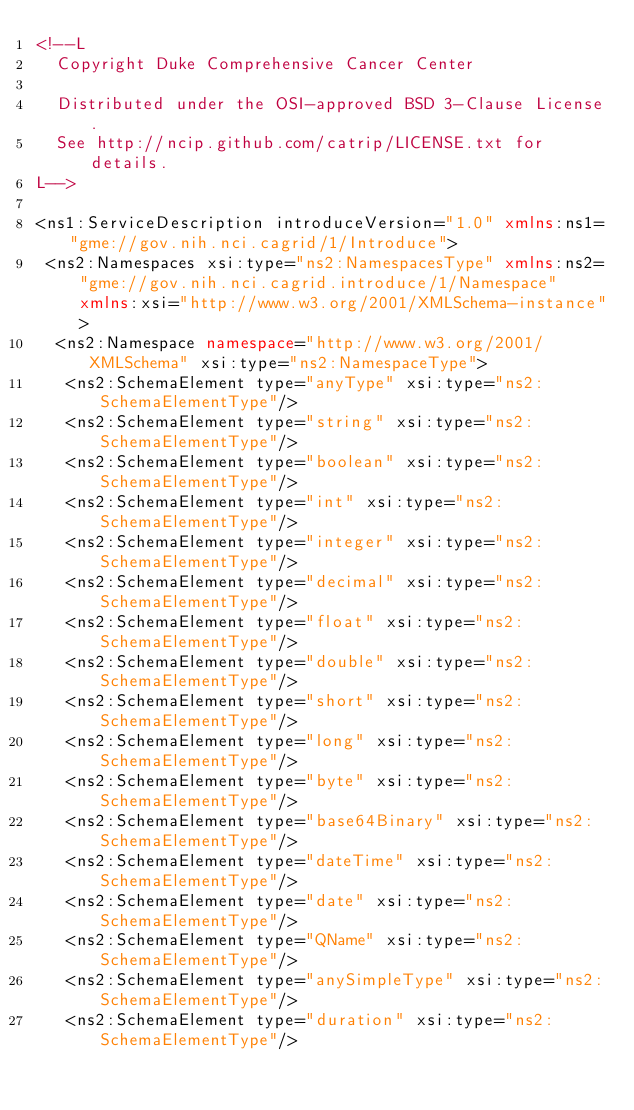Convert code to text. <code><loc_0><loc_0><loc_500><loc_500><_XML_><!--L
  Copyright Duke Comprehensive Cancer Center

  Distributed under the OSI-approved BSD 3-Clause License.
  See http://ncip.github.com/catrip/LICENSE.txt for details.
L-->

<ns1:ServiceDescription introduceVersion="1.0" xmlns:ns1="gme://gov.nih.nci.cagrid/1/Introduce">
 <ns2:Namespaces xsi:type="ns2:NamespacesType" xmlns:ns2="gme://gov.nih.nci.cagrid.introduce/1/Namespace" xmlns:xsi="http://www.w3.org/2001/XMLSchema-instance">
  <ns2:Namespace namespace="http://www.w3.org/2001/XMLSchema" xsi:type="ns2:NamespaceType">
   <ns2:SchemaElement type="anyType" xsi:type="ns2:SchemaElementType"/>
   <ns2:SchemaElement type="string" xsi:type="ns2:SchemaElementType"/>
   <ns2:SchemaElement type="boolean" xsi:type="ns2:SchemaElementType"/>
   <ns2:SchemaElement type="int" xsi:type="ns2:SchemaElementType"/>
   <ns2:SchemaElement type="integer" xsi:type="ns2:SchemaElementType"/>
   <ns2:SchemaElement type="decimal" xsi:type="ns2:SchemaElementType"/>
   <ns2:SchemaElement type="float" xsi:type="ns2:SchemaElementType"/>
   <ns2:SchemaElement type="double" xsi:type="ns2:SchemaElementType"/>
   <ns2:SchemaElement type="short" xsi:type="ns2:SchemaElementType"/>
   <ns2:SchemaElement type="long" xsi:type="ns2:SchemaElementType"/>
   <ns2:SchemaElement type="byte" xsi:type="ns2:SchemaElementType"/>
   <ns2:SchemaElement type="base64Binary" xsi:type="ns2:SchemaElementType"/>
   <ns2:SchemaElement type="dateTime" xsi:type="ns2:SchemaElementType"/>
   <ns2:SchemaElement type="date" xsi:type="ns2:SchemaElementType"/>
   <ns2:SchemaElement type="QName" xsi:type="ns2:SchemaElementType"/>
   <ns2:SchemaElement type="anySimpleType" xsi:type="ns2:SchemaElementType"/>
   <ns2:SchemaElement type="duration" xsi:type="ns2:SchemaElementType"/></code> 